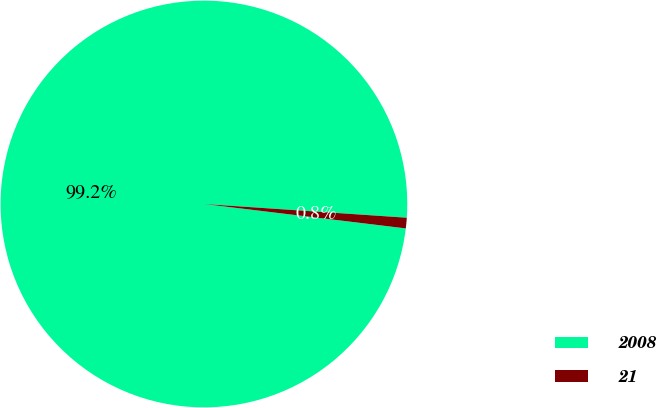<chart> <loc_0><loc_0><loc_500><loc_500><pie_chart><fcel>2008<fcel>21<nl><fcel>99.16%<fcel>0.84%<nl></chart> 